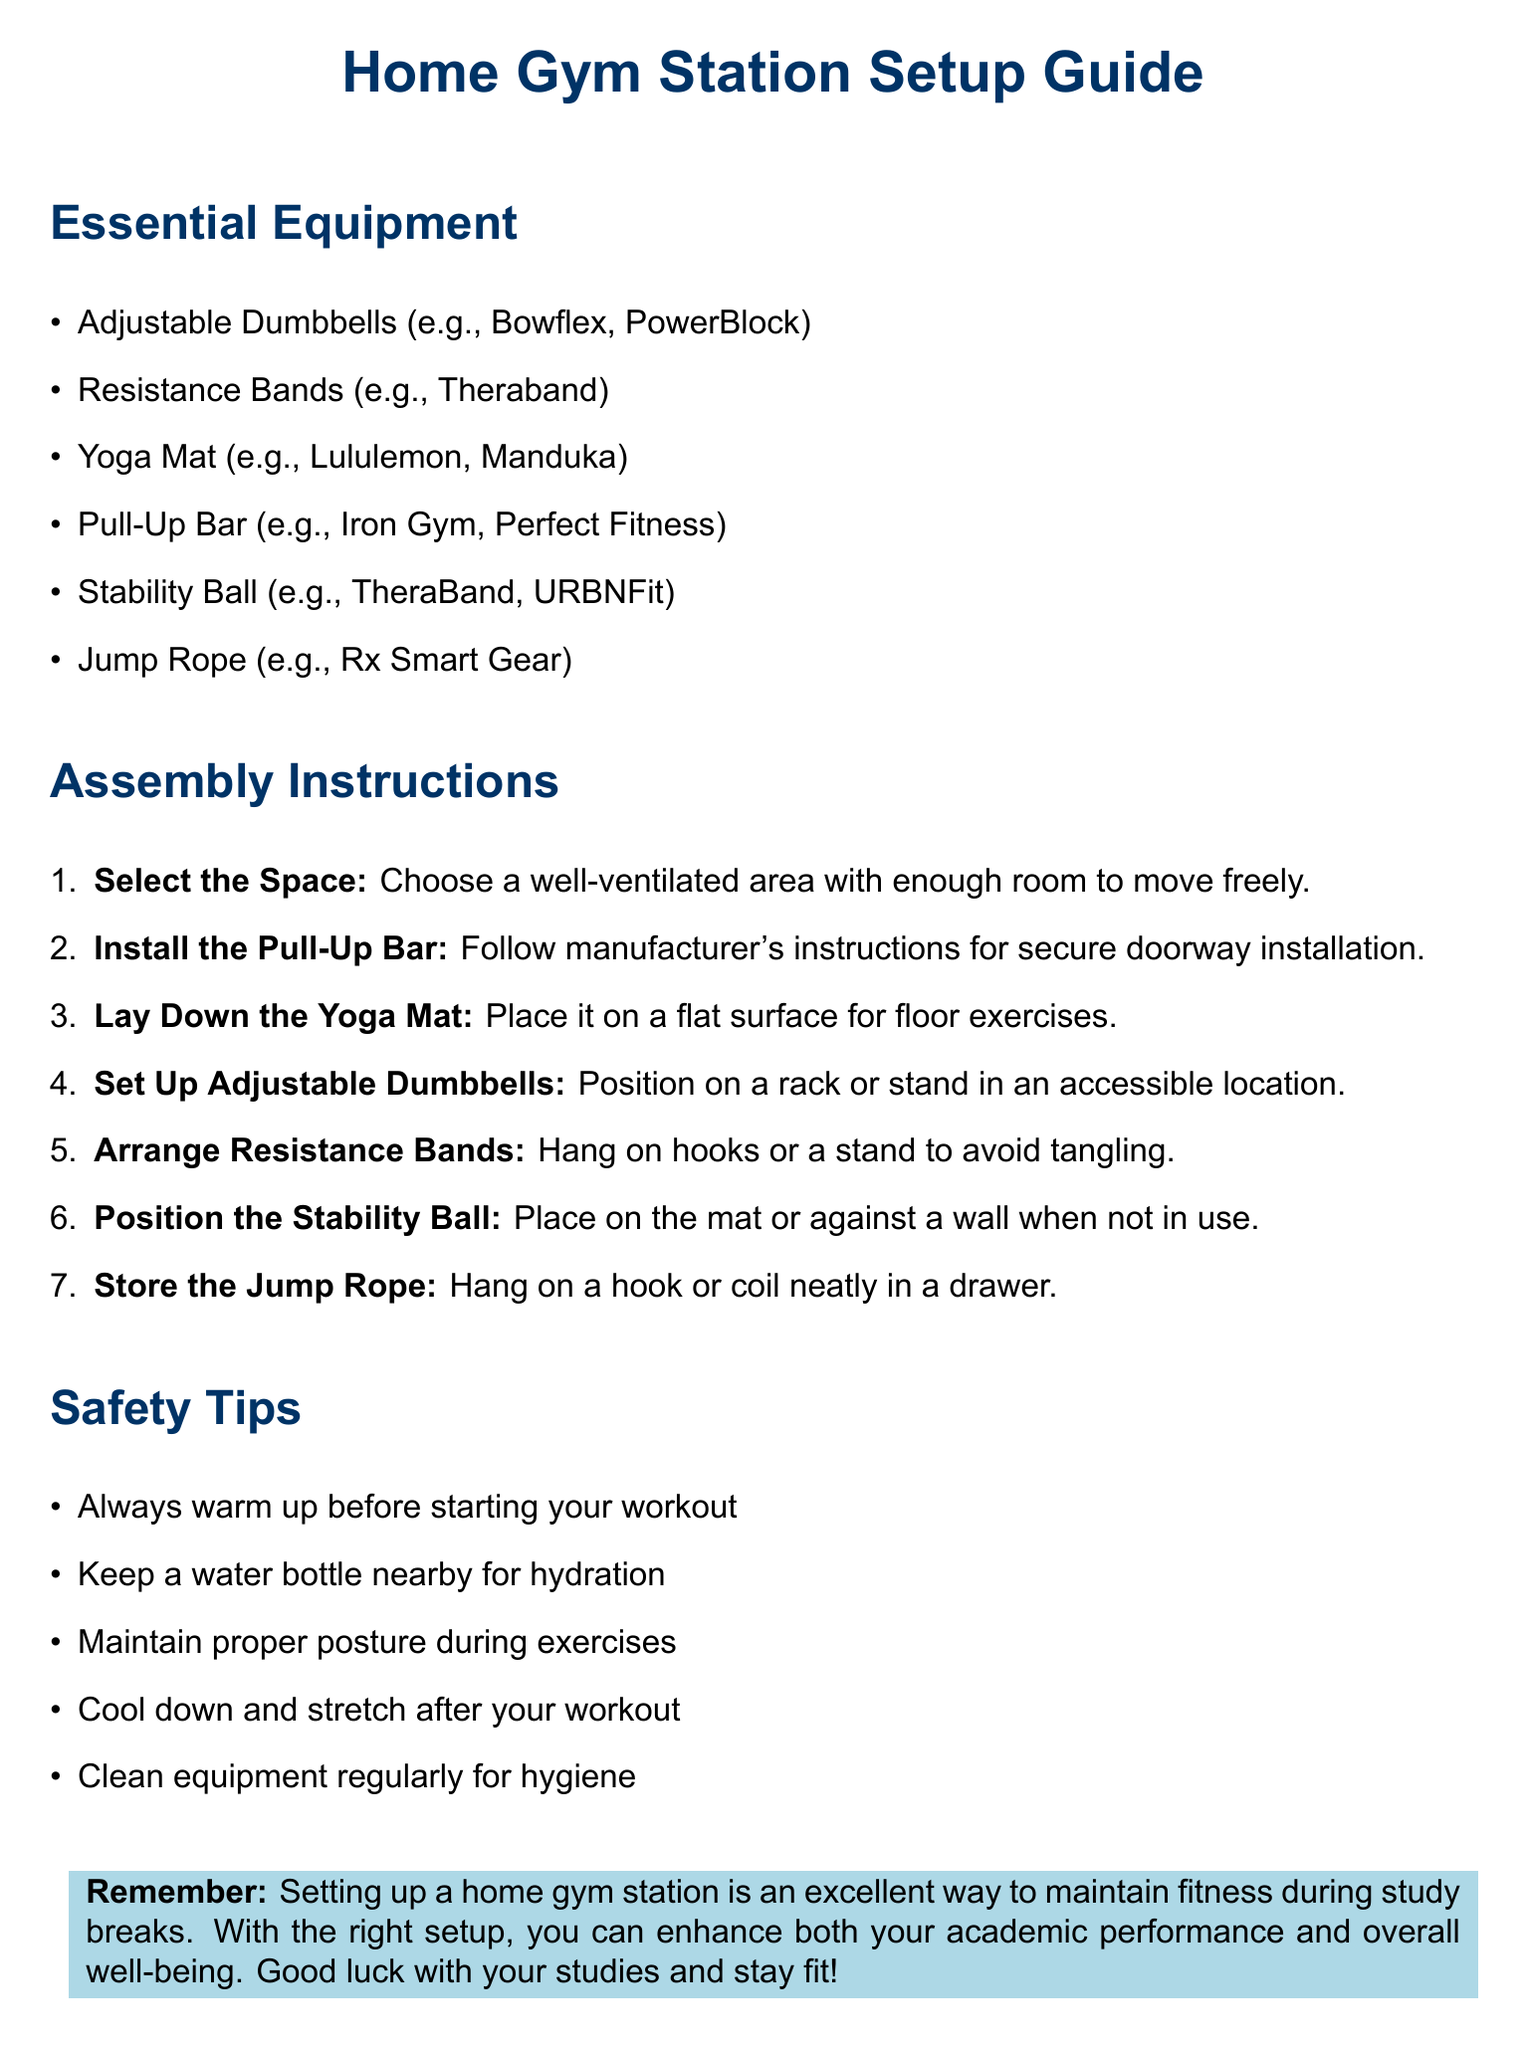what is the title of the document? The title appears at the beginning of the document in a bold format.
Answer: Home Gym Station Setup Guide how many essential equipment items are listed? The number of items can be counted in the "Essential Equipment" section.
Answer: 6 what is the first step in the assembly instructions? The first step is found in the "Assembly Instructions" section and outlines what should be done first.
Answer: Select the Space which brand of resistance bands is suggested? The brand is mentioned in the list of essential equipment provided in the document.
Answer: Theraband what safety tip emphasizes hydration? The safety tips are listed, and one mentions the importance of having a water bottle nearby.
Answer: Keep a water bottle nearby for hydration where should the yoga mat be placed? The document specifies where to lay down the yoga mat in the assembly instructions.
Answer: On a flat surface 